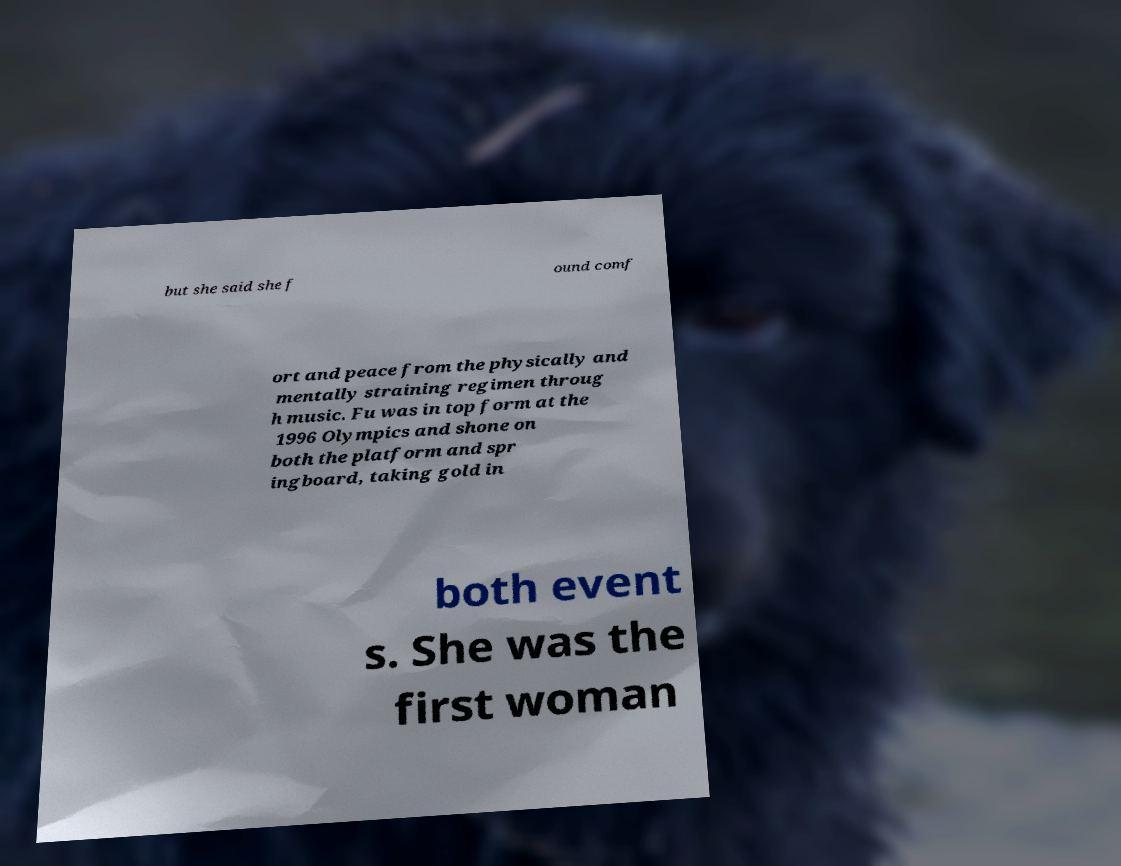Could you extract and type out the text from this image? but she said she f ound comf ort and peace from the physically and mentally straining regimen throug h music. Fu was in top form at the 1996 Olympics and shone on both the platform and spr ingboard, taking gold in both event s. She was the first woman 